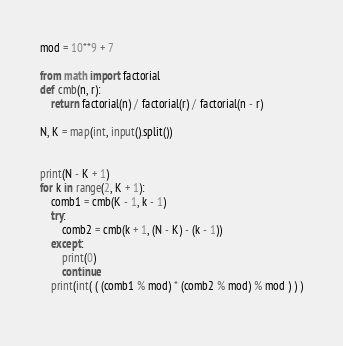<code> <loc_0><loc_0><loc_500><loc_500><_Python_>mod = 10**9 + 7

from math import factorial
def cmb(n, r):
    return factorial(n) / factorial(r) / factorial(n - r)

N, K = map(int, input().split())


print(N - K + 1)
for k in range(2, K + 1):
    comb1 = cmb(K - 1, k - 1)
    try:
        comb2 = cmb(k + 1, (N - K) - (k - 1))
    except:
        print(0)
        continue
    print(int( ( (comb1 % mod) * (comb2 % mod) % mod ) ) )
    </code> 